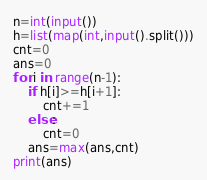<code> <loc_0><loc_0><loc_500><loc_500><_Python_>n=int(input())
h=list(map(int,input().split()))
cnt=0
ans=0
for i in range(n-1):
    if h[i]>=h[i+1]:
        cnt+=1
    else:
        cnt=0
    ans=max(ans,cnt)
print(ans)</code> 